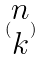Convert formula to latex. <formula><loc_0><loc_0><loc_500><loc_500>( \begin{matrix} n \\ k \end{matrix} )</formula> 